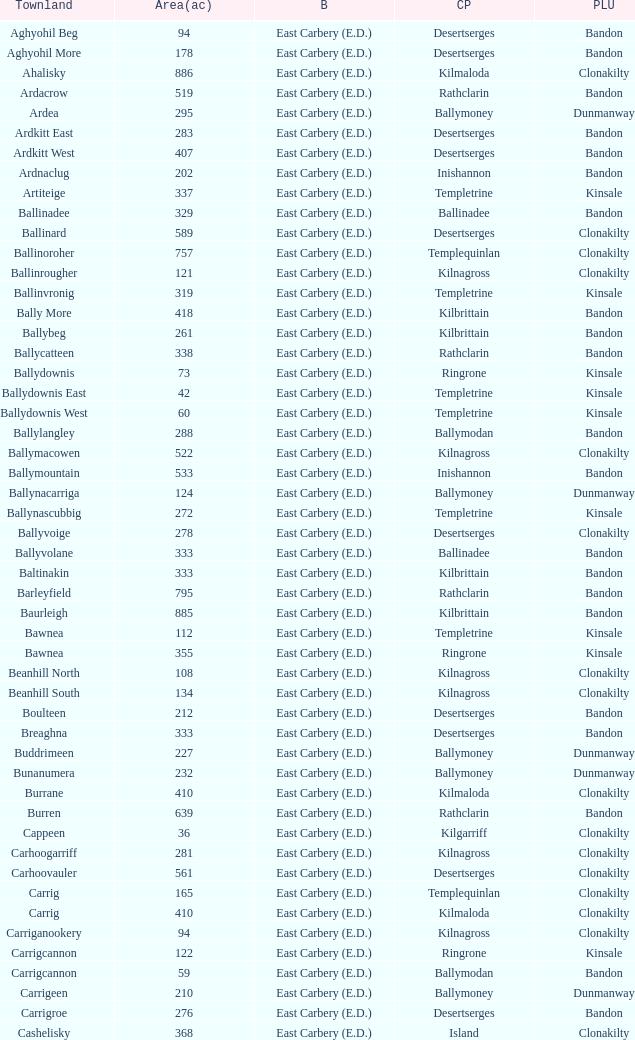What is the poor law union of the Kilmaloda townland? Clonakilty. Would you be able to parse every entry in this table? {'header': ['Townland', 'Area(ac)', 'B', 'CP', 'PLU'], 'rows': [['Aghyohil Beg', '94', 'East Carbery (E.D.)', 'Desertserges', 'Bandon'], ['Aghyohil More', '178', 'East Carbery (E.D.)', 'Desertserges', 'Bandon'], ['Ahalisky', '886', 'East Carbery (E.D.)', 'Kilmaloda', 'Clonakilty'], ['Ardacrow', '519', 'East Carbery (E.D.)', 'Rathclarin', 'Bandon'], ['Ardea', '295', 'East Carbery (E.D.)', 'Ballymoney', 'Dunmanway'], ['Ardkitt East', '283', 'East Carbery (E.D.)', 'Desertserges', 'Bandon'], ['Ardkitt West', '407', 'East Carbery (E.D.)', 'Desertserges', 'Bandon'], ['Ardnaclug', '202', 'East Carbery (E.D.)', 'Inishannon', 'Bandon'], ['Artiteige', '337', 'East Carbery (E.D.)', 'Templetrine', 'Kinsale'], ['Ballinadee', '329', 'East Carbery (E.D.)', 'Ballinadee', 'Bandon'], ['Ballinard', '589', 'East Carbery (E.D.)', 'Desertserges', 'Clonakilty'], ['Ballinoroher', '757', 'East Carbery (E.D.)', 'Templequinlan', 'Clonakilty'], ['Ballinrougher', '121', 'East Carbery (E.D.)', 'Kilnagross', 'Clonakilty'], ['Ballinvronig', '319', 'East Carbery (E.D.)', 'Templetrine', 'Kinsale'], ['Bally More', '418', 'East Carbery (E.D.)', 'Kilbrittain', 'Bandon'], ['Ballybeg', '261', 'East Carbery (E.D.)', 'Kilbrittain', 'Bandon'], ['Ballycatteen', '338', 'East Carbery (E.D.)', 'Rathclarin', 'Bandon'], ['Ballydownis', '73', 'East Carbery (E.D.)', 'Ringrone', 'Kinsale'], ['Ballydownis East', '42', 'East Carbery (E.D.)', 'Templetrine', 'Kinsale'], ['Ballydownis West', '60', 'East Carbery (E.D.)', 'Templetrine', 'Kinsale'], ['Ballylangley', '288', 'East Carbery (E.D.)', 'Ballymodan', 'Bandon'], ['Ballymacowen', '522', 'East Carbery (E.D.)', 'Kilnagross', 'Clonakilty'], ['Ballymountain', '533', 'East Carbery (E.D.)', 'Inishannon', 'Bandon'], ['Ballynacarriga', '124', 'East Carbery (E.D.)', 'Ballymoney', 'Dunmanway'], ['Ballynascubbig', '272', 'East Carbery (E.D.)', 'Templetrine', 'Kinsale'], ['Ballyvoige', '278', 'East Carbery (E.D.)', 'Desertserges', 'Clonakilty'], ['Ballyvolane', '333', 'East Carbery (E.D.)', 'Ballinadee', 'Bandon'], ['Baltinakin', '333', 'East Carbery (E.D.)', 'Kilbrittain', 'Bandon'], ['Barleyfield', '795', 'East Carbery (E.D.)', 'Rathclarin', 'Bandon'], ['Baurleigh', '885', 'East Carbery (E.D.)', 'Kilbrittain', 'Bandon'], ['Bawnea', '112', 'East Carbery (E.D.)', 'Templetrine', 'Kinsale'], ['Bawnea', '355', 'East Carbery (E.D.)', 'Ringrone', 'Kinsale'], ['Beanhill North', '108', 'East Carbery (E.D.)', 'Kilnagross', 'Clonakilty'], ['Beanhill South', '134', 'East Carbery (E.D.)', 'Kilnagross', 'Clonakilty'], ['Boulteen', '212', 'East Carbery (E.D.)', 'Desertserges', 'Bandon'], ['Breaghna', '333', 'East Carbery (E.D.)', 'Desertserges', 'Bandon'], ['Buddrimeen', '227', 'East Carbery (E.D.)', 'Ballymoney', 'Dunmanway'], ['Bunanumera', '232', 'East Carbery (E.D.)', 'Ballymoney', 'Dunmanway'], ['Burrane', '410', 'East Carbery (E.D.)', 'Kilmaloda', 'Clonakilty'], ['Burren', '639', 'East Carbery (E.D.)', 'Rathclarin', 'Bandon'], ['Cappeen', '36', 'East Carbery (E.D.)', 'Kilgarriff', 'Clonakilty'], ['Carhoogarriff', '281', 'East Carbery (E.D.)', 'Kilnagross', 'Clonakilty'], ['Carhoovauler', '561', 'East Carbery (E.D.)', 'Desertserges', 'Clonakilty'], ['Carrig', '165', 'East Carbery (E.D.)', 'Templequinlan', 'Clonakilty'], ['Carrig', '410', 'East Carbery (E.D.)', 'Kilmaloda', 'Clonakilty'], ['Carriganookery', '94', 'East Carbery (E.D.)', 'Kilnagross', 'Clonakilty'], ['Carrigcannon', '122', 'East Carbery (E.D.)', 'Ringrone', 'Kinsale'], ['Carrigcannon', '59', 'East Carbery (E.D.)', 'Ballymodan', 'Bandon'], ['Carrigeen', '210', 'East Carbery (E.D.)', 'Ballymoney', 'Dunmanway'], ['Carrigroe', '276', 'East Carbery (E.D.)', 'Desertserges', 'Bandon'], ['Cashelisky', '368', 'East Carbery (E.D.)', 'Island', 'Clonakilty'], ['Castlederry', '148', 'East Carbery (E.D.)', 'Desertserges', 'Clonakilty'], ['Clashafree', '477', 'East Carbery (E.D.)', 'Ballymodan', 'Bandon'], ['Clashreagh', '132', 'East Carbery (E.D.)', 'Templetrine', 'Kinsale'], ['Clogagh North', '173', 'East Carbery (E.D.)', 'Kilmaloda', 'Clonakilty'], ['Clogagh South', '282', 'East Carbery (E.D.)', 'Kilmaloda', 'Clonakilty'], ['Cloghane', '488', 'East Carbery (E.D.)', 'Ballinadee', 'Bandon'], ['Clogheenavodig', '70', 'East Carbery (E.D.)', 'Ballymodan', 'Bandon'], ['Cloghmacsimon', '258', 'East Carbery (E.D.)', 'Ballymodan', 'Bandon'], ['Cloheen', '360', 'East Carbery (E.D.)', 'Kilgarriff', 'Clonakilty'], ['Cloheen', '80', 'East Carbery (E.D.)', 'Island', 'Clonakilty'], ['Clonbouig', '209', 'East Carbery (E.D.)', 'Templetrine', 'Kinsale'], ['Clonbouig', '219', 'East Carbery (E.D.)', 'Ringrone', 'Kinsale'], ['Cloncouse', '241', 'East Carbery (E.D.)', 'Ballinadee', 'Bandon'], ['Clooncalla Beg', '219', 'East Carbery (E.D.)', 'Rathclarin', 'Bandon'], ['Clooncalla More', '543', 'East Carbery (E.D.)', 'Rathclarin', 'Bandon'], ['Cloonderreen', '291', 'East Carbery (E.D.)', 'Rathclarin', 'Bandon'], ['Coolmain', '450', 'East Carbery (E.D.)', 'Ringrone', 'Kinsale'], ['Corravreeda East', '258', 'East Carbery (E.D.)', 'Ballymodan', 'Bandon'], ['Corravreeda West', '169', 'East Carbery (E.D.)', 'Ballymodan', 'Bandon'], ['Cripplehill', '125', 'East Carbery (E.D.)', 'Ballymodan', 'Bandon'], ['Cripplehill', '93', 'East Carbery (E.D.)', 'Kilbrittain', 'Bandon'], ['Crohane', '91', 'East Carbery (E.D.)', 'Kilnagross', 'Clonakilty'], ['Crohane East', '108', 'East Carbery (E.D.)', 'Desertserges', 'Clonakilty'], ['Crohane West', '69', 'East Carbery (E.D.)', 'Desertserges', 'Clonakilty'], ['Crohane (or Bandon)', '204', 'East Carbery (E.D.)', 'Desertserges', 'Clonakilty'], ['Crohane (or Bandon)', '250', 'East Carbery (E.D.)', 'Kilnagross', 'Clonakilty'], ['Currabeg', '173', 'East Carbery (E.D.)', 'Ballymoney', 'Dunmanway'], ['Curraghcrowly East', '327', 'East Carbery (E.D.)', 'Ballymoney', 'Dunmanway'], ['Curraghcrowly West', '242', 'East Carbery (E.D.)', 'Ballymoney', 'Dunmanway'], ['Curraghgrane More', '110', 'East Carbery (E.D.)', 'Desert', 'Clonakilty'], ['Currane', '156', 'East Carbery (E.D.)', 'Desertserges', 'Clonakilty'], ['Curranure', '362', 'East Carbery (E.D.)', 'Inishannon', 'Bandon'], ['Currarane', '100', 'East Carbery (E.D.)', 'Templetrine', 'Kinsale'], ['Currarane', '271', 'East Carbery (E.D.)', 'Ringrone', 'Kinsale'], ['Derrigra', '177', 'East Carbery (E.D.)', 'Ballymoney', 'Dunmanway'], ['Derrigra West', '320', 'East Carbery (E.D.)', 'Ballymoney', 'Dunmanway'], ['Derry', '140', 'East Carbery (E.D.)', 'Desertserges', 'Clonakilty'], ['Derrymeeleen', '441', 'East Carbery (E.D.)', 'Desertserges', 'Clonakilty'], ['Desert', '339', 'East Carbery (E.D.)', 'Desert', 'Clonakilty'], ['Drombofinny', '86', 'East Carbery (E.D.)', 'Desertserges', 'Bandon'], ['Dromgarriff', '335', 'East Carbery (E.D.)', 'Kilmaloda', 'Clonakilty'], ['Dromgarriff East', '385', 'East Carbery (E.D.)', 'Kilnagross', 'Clonakilty'], ['Dromgarriff West', '138', 'East Carbery (E.D.)', 'Kilnagross', 'Clonakilty'], ['Dromkeen', '673', 'East Carbery (E.D.)', 'Inishannon', 'Bandon'], ['Edencurra', '516', 'East Carbery (E.D.)', 'Ballymoney', 'Dunmanway'], ['Farran', '502', 'East Carbery (E.D.)', 'Kilmaloda', 'Clonakilty'], ['Farranagow', '99', 'East Carbery (E.D.)', 'Inishannon', 'Bandon'], ['Farrannagark', '290', 'East Carbery (E.D.)', 'Rathclarin', 'Bandon'], ['Farrannasheshery', '304', 'East Carbery (E.D.)', 'Desertserges', 'Bandon'], ['Fourcuil', '125', 'East Carbery (E.D.)', 'Kilgarriff', 'Clonakilty'], ['Fourcuil', '244', 'East Carbery (E.D.)', 'Templebryan', 'Clonakilty'], ['Garranbeg', '170', 'East Carbery (E.D.)', 'Ballymodan', 'Bandon'], ['Garraneanasig', '270', 'East Carbery (E.D.)', 'Ringrone', 'Kinsale'], ['Garraneard', '276', 'East Carbery (E.D.)', 'Kilnagross', 'Clonakilty'], ['Garranecore', '144', 'East Carbery (E.D.)', 'Templebryan', 'Clonakilty'], ['Garranecore', '186', 'East Carbery (E.D.)', 'Kilgarriff', 'Clonakilty'], ['Garranefeen', '478', 'East Carbery (E.D.)', 'Rathclarin', 'Bandon'], ['Garraneishal', '121', 'East Carbery (E.D.)', 'Kilnagross', 'Clonakilty'], ['Garranelahan', '126', 'East Carbery (E.D.)', 'Desertserges', 'Bandon'], ['Garranereagh', '398', 'East Carbery (E.D.)', 'Ringrone', 'Kinsale'], ['Garranes', '416', 'East Carbery (E.D.)', 'Desertserges', 'Clonakilty'], ['Garranure', '436', 'East Carbery (E.D.)', 'Ballymoney', 'Dunmanway'], ['Garryndruig', '856', 'East Carbery (E.D.)', 'Rathclarin', 'Bandon'], ['Glan', '194', 'East Carbery (E.D.)', 'Ballymoney', 'Dunmanway'], ['Glanavaud', '98', 'East Carbery (E.D.)', 'Ringrone', 'Kinsale'], ['Glanavirane', '107', 'East Carbery (E.D.)', 'Templetrine', 'Kinsale'], ['Glanavirane', '91', 'East Carbery (E.D.)', 'Ringrone', 'Kinsale'], ['Glanduff', '464', 'East Carbery (E.D.)', 'Rathclarin', 'Bandon'], ['Grillagh', '136', 'East Carbery (E.D.)', 'Kilnagross', 'Clonakilty'], ['Grillagh', '316', 'East Carbery (E.D.)', 'Ballymoney', 'Dunmanway'], ['Hacketstown', '182', 'East Carbery (E.D.)', 'Templetrine', 'Kinsale'], ['Inchafune', '871', 'East Carbery (E.D.)', 'Ballymoney', 'Dunmanway'], ['Inchydoney Island', '474', 'East Carbery (E.D.)', 'Island', 'Clonakilty'], ['Kilbeloge', '216', 'East Carbery (E.D.)', 'Desertserges', 'Clonakilty'], ['Kilbree', '284', 'East Carbery (E.D.)', 'Island', 'Clonakilty'], ['Kilbrittain', '483', 'East Carbery (E.D.)', 'Kilbrittain', 'Bandon'], ['Kilcaskan', '221', 'East Carbery (E.D.)', 'Ballymoney', 'Dunmanway'], ['Kildarra', '463', 'East Carbery (E.D.)', 'Ballinadee', 'Bandon'], ['Kilgarriff', '835', 'East Carbery (E.D.)', 'Kilgarriff', 'Clonakilty'], ['Kilgobbin', '1263', 'East Carbery (E.D.)', 'Ballinadee', 'Bandon'], ['Kill North', '136', 'East Carbery (E.D.)', 'Desertserges', 'Clonakilty'], ['Kill South', '139', 'East Carbery (E.D.)', 'Desertserges', 'Clonakilty'], ['Killanamaul', '220', 'East Carbery (E.D.)', 'Kilbrittain', 'Bandon'], ['Killaneetig', '342', 'East Carbery (E.D.)', 'Ballinadee', 'Bandon'], ['Killavarrig', '708', 'East Carbery (E.D.)', 'Timoleague', 'Clonakilty'], ['Killeen', '309', 'East Carbery (E.D.)', 'Desertserges', 'Clonakilty'], ['Killeens', '132', 'East Carbery (E.D.)', 'Templetrine', 'Kinsale'], ['Kilmacsimon', '219', 'East Carbery (E.D.)', 'Ballinadee', 'Bandon'], ['Kilmaloda', '634', 'East Carbery (E.D.)', 'Kilmaloda', 'Clonakilty'], ['Kilmoylerane North', '306', 'East Carbery (E.D.)', 'Desertserges', 'Clonakilty'], ['Kilmoylerane South', '324', 'East Carbery (E.D.)', 'Desertserges', 'Clonakilty'], ['Kilnameela', '397', 'East Carbery (E.D.)', 'Desertserges', 'Bandon'], ['Kilrush', '189', 'East Carbery (E.D.)', 'Desertserges', 'Bandon'], ['Kilshinahan', '528', 'East Carbery (E.D.)', 'Kilbrittain', 'Bandon'], ['Kilvinane', '199', 'East Carbery (E.D.)', 'Ballymoney', 'Dunmanway'], ['Kilvurra', '356', 'East Carbery (E.D.)', 'Ballymoney', 'Dunmanway'], ['Knockacullen', '381', 'East Carbery (E.D.)', 'Desertserges', 'Clonakilty'], ['Knockaneady', '393', 'East Carbery (E.D.)', 'Ballymoney', 'Dunmanway'], ['Knockaneroe', '127', 'East Carbery (E.D.)', 'Templetrine', 'Kinsale'], ['Knockanreagh', '139', 'East Carbery (E.D.)', 'Ballymodan', 'Bandon'], ['Knockbrown', '312', 'East Carbery (E.D.)', 'Kilbrittain', 'Bandon'], ['Knockbrown', '510', 'East Carbery (E.D.)', 'Kilmaloda', 'Bandon'], ['Knockeenbwee Lower', '213', 'East Carbery (E.D.)', 'Dromdaleague', 'Skibbereen'], ['Knockeenbwee Upper', '229', 'East Carbery (E.D.)', 'Dromdaleague', 'Skibbereen'], ['Knockeencon', '108', 'East Carbery (E.D.)', 'Tullagh', 'Skibbereen'], ['Knockmacool', '241', 'East Carbery (E.D.)', 'Desertserges', 'Bandon'], ['Knocknacurra', '422', 'East Carbery (E.D.)', 'Ballinadee', 'Bandon'], ['Knocknagappul', '507', 'East Carbery (E.D.)', 'Ballinadee', 'Bandon'], ['Knocknanuss', '394', 'East Carbery (E.D.)', 'Desertserges', 'Clonakilty'], ['Knocknastooka', '118', 'East Carbery (E.D.)', 'Desertserges', 'Bandon'], ['Knockroe', '601', 'East Carbery (E.D.)', 'Inishannon', 'Bandon'], ['Knocks', '540', 'East Carbery (E.D.)', 'Desertserges', 'Clonakilty'], ['Knockskagh', '489', 'East Carbery (E.D.)', 'Kilgarriff', 'Clonakilty'], ['Knoppoge', '567', 'East Carbery (E.D.)', 'Kilbrittain', 'Bandon'], ['Lackanalooha', '209', 'East Carbery (E.D.)', 'Kilnagross', 'Clonakilty'], ['Lackenagobidane', '48', 'East Carbery (E.D.)', 'Island', 'Clonakilty'], ['Lisbehegh', '255', 'East Carbery (E.D.)', 'Desertserges', 'Clonakilty'], ['Lisheen', '44', 'East Carbery (E.D.)', 'Templetrine', 'Kinsale'], ['Lisheenaleen', '267', 'East Carbery (E.D.)', 'Rathclarin', 'Bandon'], ['Lisnacunna', '529', 'East Carbery (E.D.)', 'Desertserges', 'Bandon'], ['Lisroe', '91', 'East Carbery (E.D.)', 'Kilgarriff', 'Clonakilty'], ['Lissaphooca', '513', 'East Carbery (E.D.)', 'Ballymodan', 'Bandon'], ['Lisselane', '429', 'East Carbery (E.D.)', 'Kilnagross', 'Clonakilty'], ['Madame', '273', 'East Carbery (E.D.)', 'Kilmaloda', 'Clonakilty'], ['Madame', '41', 'East Carbery (E.D.)', 'Kilnagross', 'Clonakilty'], ['Maulbrack East', '100', 'East Carbery (E.D.)', 'Desertserges', 'Bandon'], ['Maulbrack West', '242', 'East Carbery (E.D.)', 'Desertserges', 'Bandon'], ['Maulmane', '219', 'East Carbery (E.D.)', 'Kilbrittain', 'Bandon'], ['Maulnageragh', '135', 'East Carbery (E.D.)', 'Kilnagross', 'Clonakilty'], ['Maulnarouga North', '81', 'East Carbery (E.D.)', 'Desertserges', 'Bandon'], ['Maulnarouga South', '374', 'East Carbery (E.D.)', 'Desertserges', 'Bandon'], ['Maulnaskehy', '14', 'East Carbery (E.D.)', 'Kilgarriff', 'Clonakilty'], ['Maulrour', '244', 'East Carbery (E.D.)', 'Desertserges', 'Clonakilty'], ['Maulrour', '340', 'East Carbery (E.D.)', 'Kilmaloda', 'Clonakilty'], ['Maulskinlahane', '245', 'East Carbery (E.D.)', 'Kilbrittain', 'Bandon'], ['Miles', '268', 'East Carbery (E.D.)', 'Kilgarriff', 'Clonakilty'], ['Moanarone', '235', 'East Carbery (E.D.)', 'Ballymodan', 'Bandon'], ['Monteen', '589', 'East Carbery (E.D.)', 'Kilmaloda', 'Clonakilty'], ['Phale Lower', '287', 'East Carbery (E.D.)', 'Ballymoney', 'Dunmanway'], ['Phale Upper', '234', 'East Carbery (E.D.)', 'Ballymoney', 'Dunmanway'], ['Ratharoon East', '810', 'East Carbery (E.D.)', 'Ballinadee', 'Bandon'], ['Ratharoon West', '383', 'East Carbery (E.D.)', 'Ballinadee', 'Bandon'], ['Rathdrought', '1242', 'East Carbery (E.D.)', 'Ballinadee', 'Bandon'], ['Reengarrigeen', '560', 'East Carbery (E.D.)', 'Kilmaloda', 'Clonakilty'], ['Reenroe', '123', 'East Carbery (E.D.)', 'Kilgarriff', 'Clonakilty'], ['Rochestown', '104', 'East Carbery (E.D.)', 'Templetrine', 'Kinsale'], ['Rockfort', '308', 'East Carbery (E.D.)', 'Brinny', 'Bandon'], ['Rockhouse', '82', 'East Carbery (E.D.)', 'Ballinadee', 'Bandon'], ['Scartagh', '186', 'East Carbery (E.D.)', 'Kilgarriff', 'Clonakilty'], ['Shanakill', '197', 'East Carbery (E.D.)', 'Rathclarin', 'Bandon'], ['Shanaway East', '386', 'East Carbery (E.D.)', 'Ballymoney', 'Dunmanway'], ['Shanaway Middle', '296', 'East Carbery (E.D.)', 'Ballymoney', 'Dunmanway'], ['Shanaway West', '266', 'East Carbery (E.D.)', 'Ballymoney', 'Dunmanway'], ['Skeaf', '452', 'East Carbery (E.D.)', 'Kilmaloda', 'Clonakilty'], ['Skeaf East', '371', 'East Carbery (E.D.)', 'Kilmaloda', 'Clonakilty'], ['Skeaf West', '477', 'East Carbery (E.D.)', 'Kilmaloda', 'Clonakilty'], ['Skevanish', '359', 'East Carbery (E.D.)', 'Inishannon', 'Bandon'], ['Steilaneigh', '42', 'East Carbery (E.D.)', 'Templetrine', 'Kinsale'], ['Tawnies Lower', '238', 'East Carbery (E.D.)', 'Kilgarriff', 'Clonakilty'], ['Tawnies Upper', '321', 'East Carbery (E.D.)', 'Kilgarriff', 'Clonakilty'], ['Templebryan North', '436', 'East Carbery (E.D.)', 'Templebryan', 'Clonakilty'], ['Templebryan South', '363', 'East Carbery (E.D.)', 'Templebryan', 'Clonakilty'], ['Tullig', '135', 'East Carbery (E.D.)', 'Kilmaloda', 'Clonakilty'], ['Tullyland', '348', 'East Carbery (E.D.)', 'Ballymodan', 'Bandon'], ['Tullyland', '506', 'East Carbery (E.D.)', 'Ballinadee', 'Bandon'], ['Tullymurrihy', '665', 'East Carbery (E.D.)', 'Desertserges', 'Bandon'], ['Youghals', '109', 'East Carbery (E.D.)', 'Island', 'Clonakilty']]} 